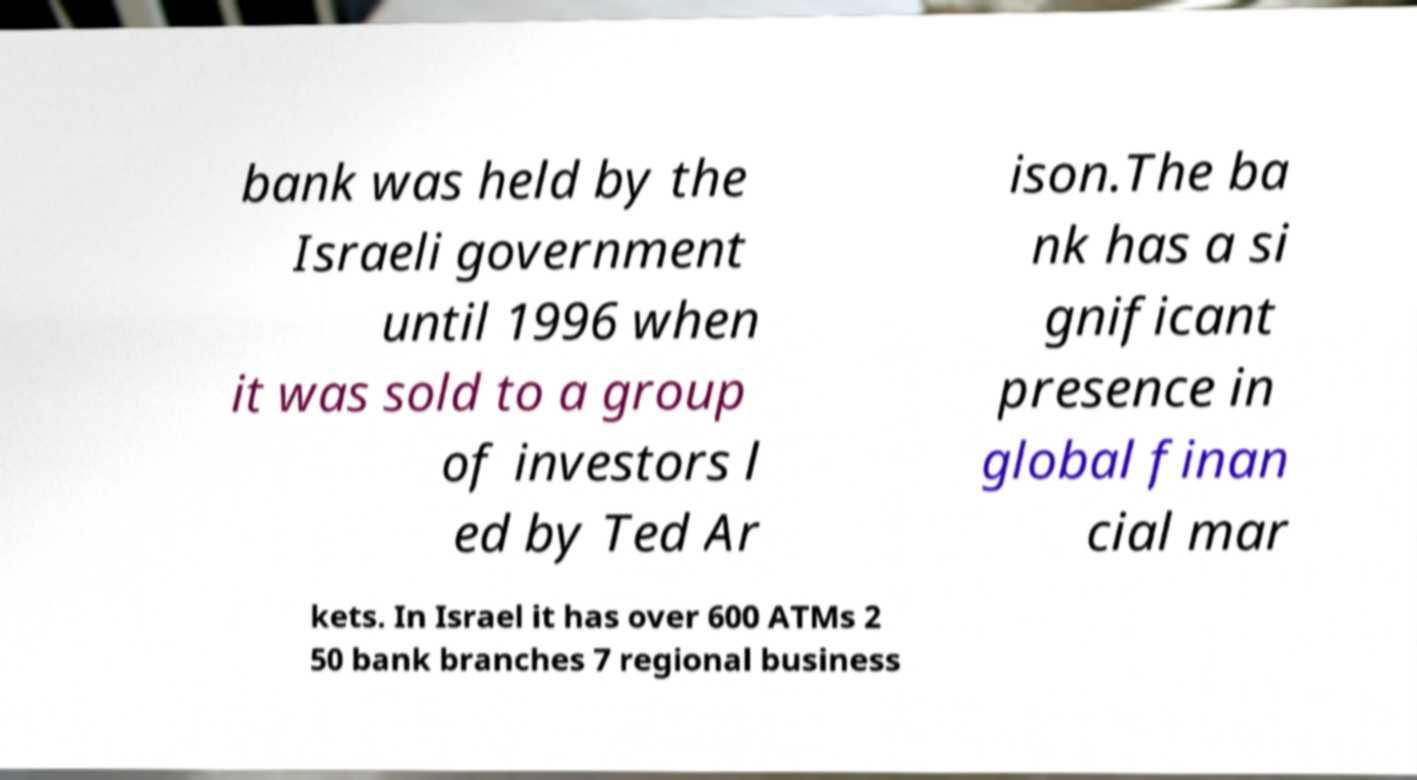There's text embedded in this image that I need extracted. Can you transcribe it verbatim? bank was held by the Israeli government until 1996 when it was sold to a group of investors l ed by Ted Ar ison.The ba nk has a si gnificant presence in global finan cial mar kets. In Israel it has over 600 ATMs 2 50 bank branches 7 regional business 